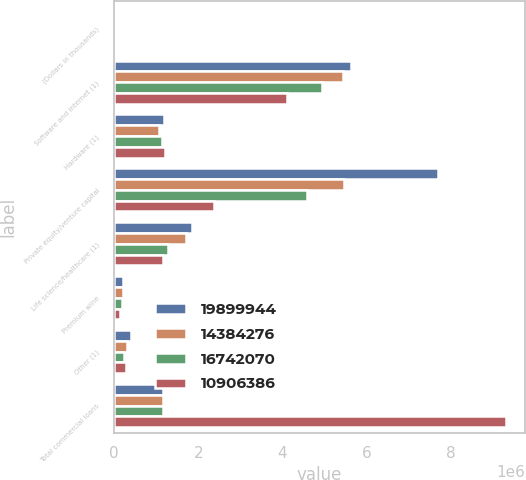Convert chart. <chart><loc_0><loc_0><loc_500><loc_500><stacked_bar_chart><ecel><fcel>(Dollars in thousands)<fcel>Software and internet (1)<fcel>Hardware (1)<fcel>Private equity/venture capital<fcel>Life science/healthcare (1)<fcel>Premium wine<fcel>Other (1)<fcel>Total commercial loans<nl><fcel>1.98999e+07<fcel>2016<fcel>5.62703e+06<fcel>1.1804e+06<fcel>7.69115e+06<fcel>1.853e+06<fcel>200156<fcel>393551<fcel>1.17022e+06<nl><fcel>1.43843e+07<fcel>2015<fcel>5.43792e+06<fcel>1.07153e+06<fcel>5.46758e+06<fcel>1.71064e+06<fcel>201175<fcel>312278<fcel>1.17022e+06<nl><fcel>1.67421e+07<fcel>2014<fcel>4.95468e+06<fcel>1.13101e+06<fcel>4.58291e+06<fcel>1.2899e+06<fcel>187568<fcel>234551<fcel>1.17022e+06<nl><fcel>1.09064e+07<fcel>2013<fcel>4.10264e+06<fcel>1.21303e+06<fcel>2.38605e+06<fcel>1.17022e+06<fcel>149841<fcel>288904<fcel>9.31069e+06<nl></chart> 